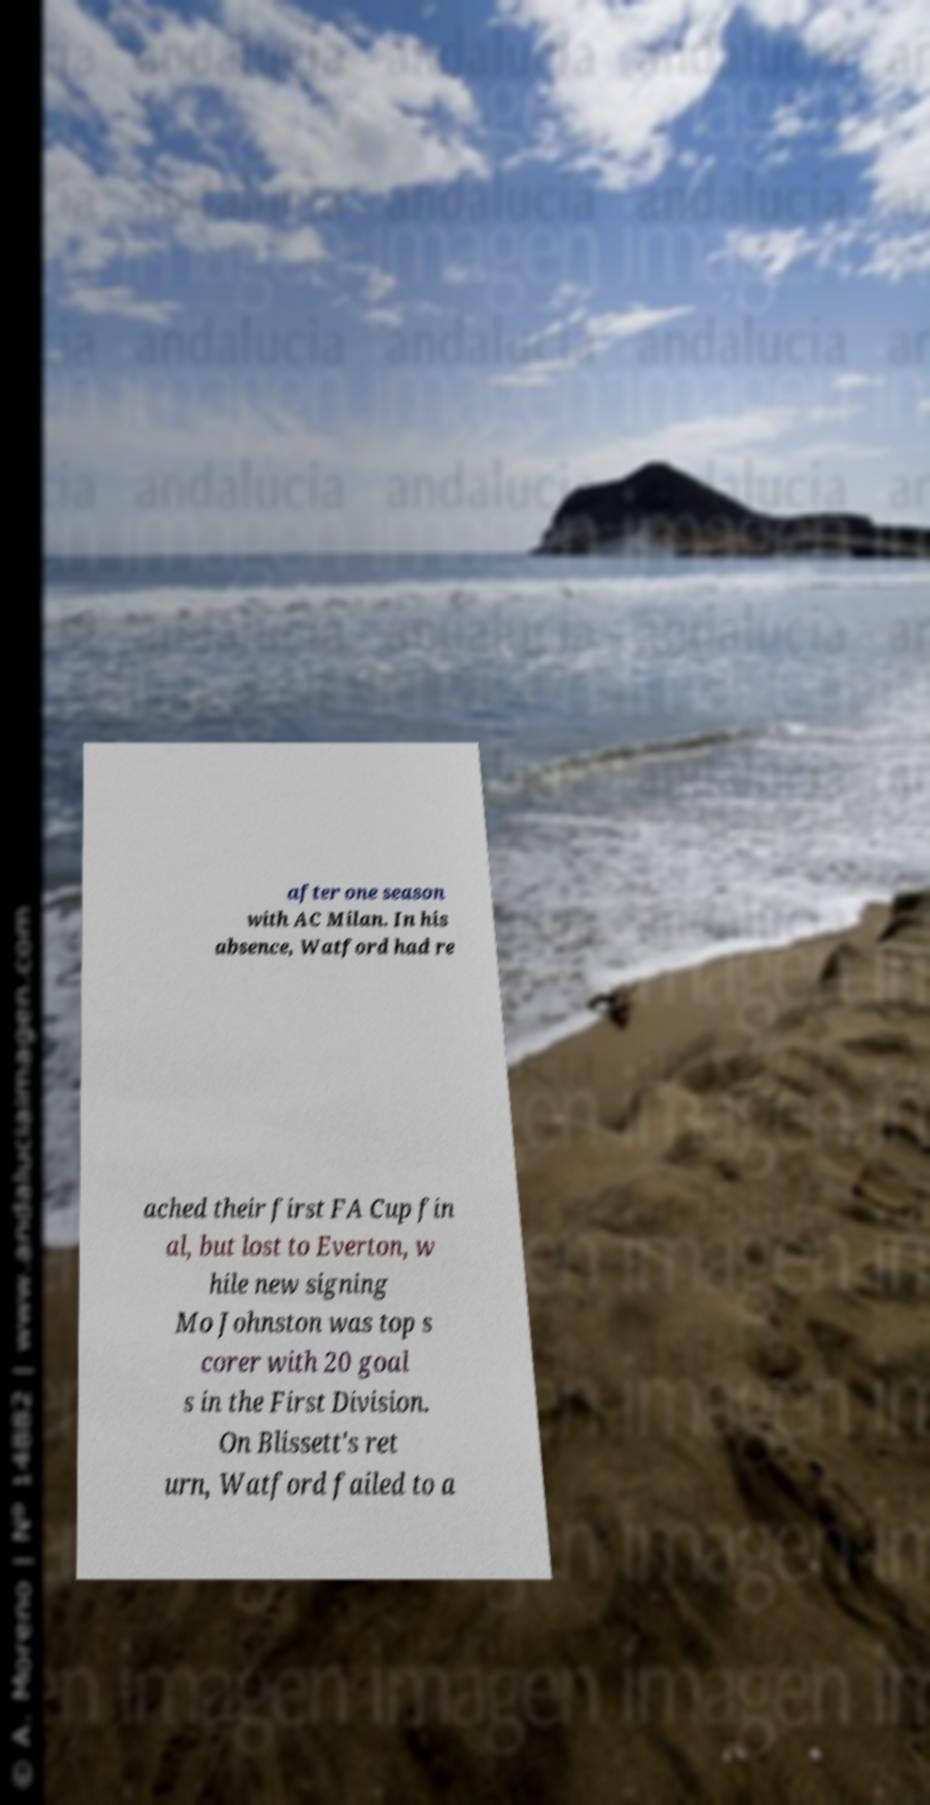Could you assist in decoding the text presented in this image and type it out clearly? after one season with AC Milan. In his absence, Watford had re ached their first FA Cup fin al, but lost to Everton, w hile new signing Mo Johnston was top s corer with 20 goal s in the First Division. On Blissett's ret urn, Watford failed to a 